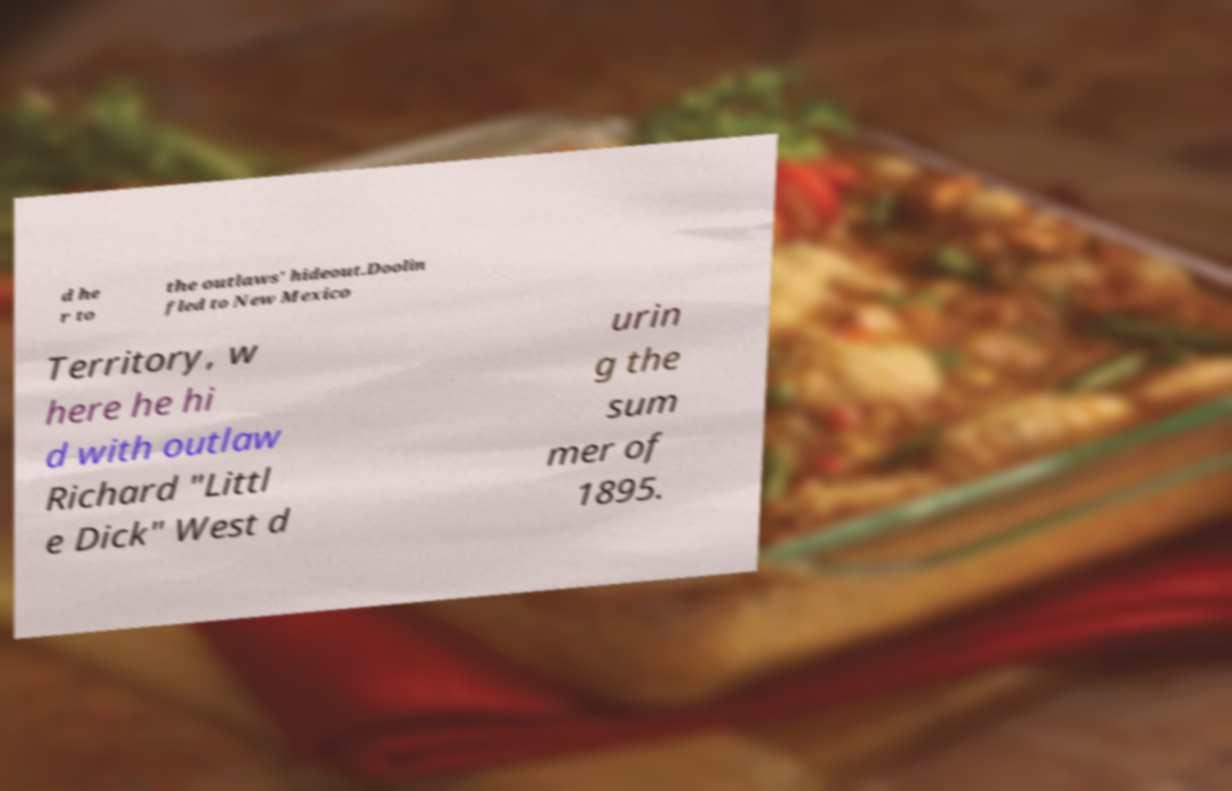Could you assist in decoding the text presented in this image and type it out clearly? d he r to the outlaws' hideout.Doolin fled to New Mexico Territory, w here he hi d with outlaw Richard "Littl e Dick" West d urin g the sum mer of 1895. 